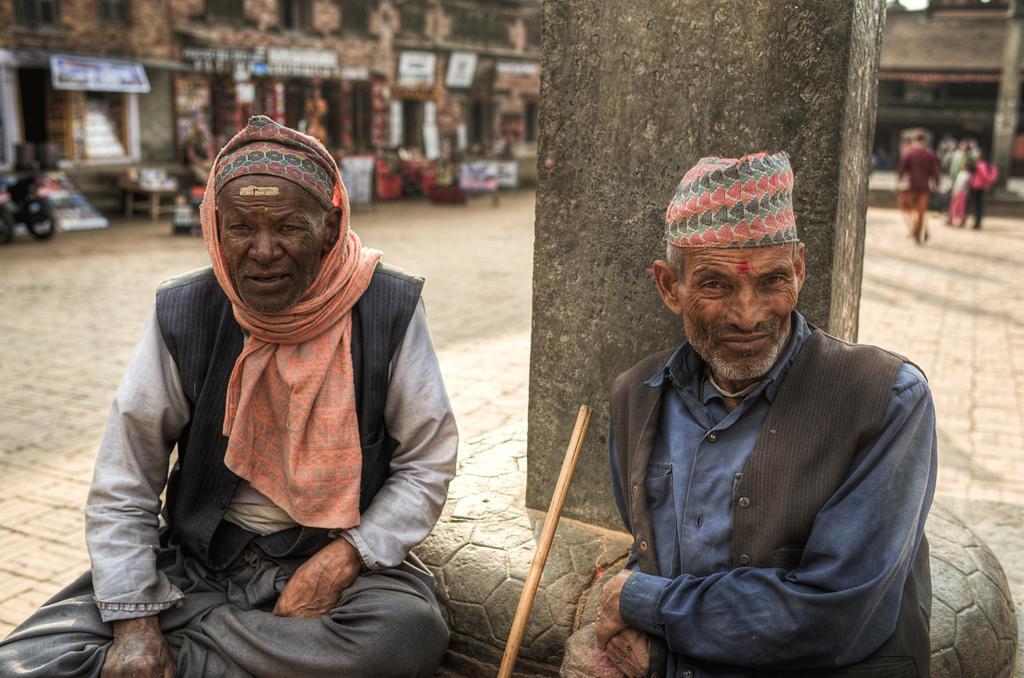Describe this image in one or two sentences. In this image in the foreground there are few people visible, between them there is a stick visible in front of pillar, in the background there is a building , in front of building there are few peoples and bicycle visible on the left side. 